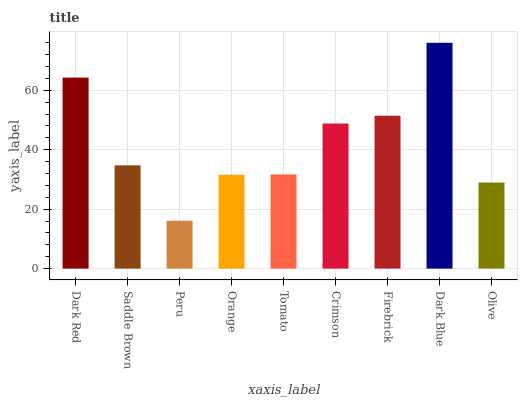Is Saddle Brown the minimum?
Answer yes or no. No. Is Saddle Brown the maximum?
Answer yes or no. No. Is Dark Red greater than Saddle Brown?
Answer yes or no. Yes. Is Saddle Brown less than Dark Red?
Answer yes or no. Yes. Is Saddle Brown greater than Dark Red?
Answer yes or no. No. Is Dark Red less than Saddle Brown?
Answer yes or no. No. Is Saddle Brown the high median?
Answer yes or no. Yes. Is Saddle Brown the low median?
Answer yes or no. Yes. Is Tomato the high median?
Answer yes or no. No. Is Dark Red the low median?
Answer yes or no. No. 